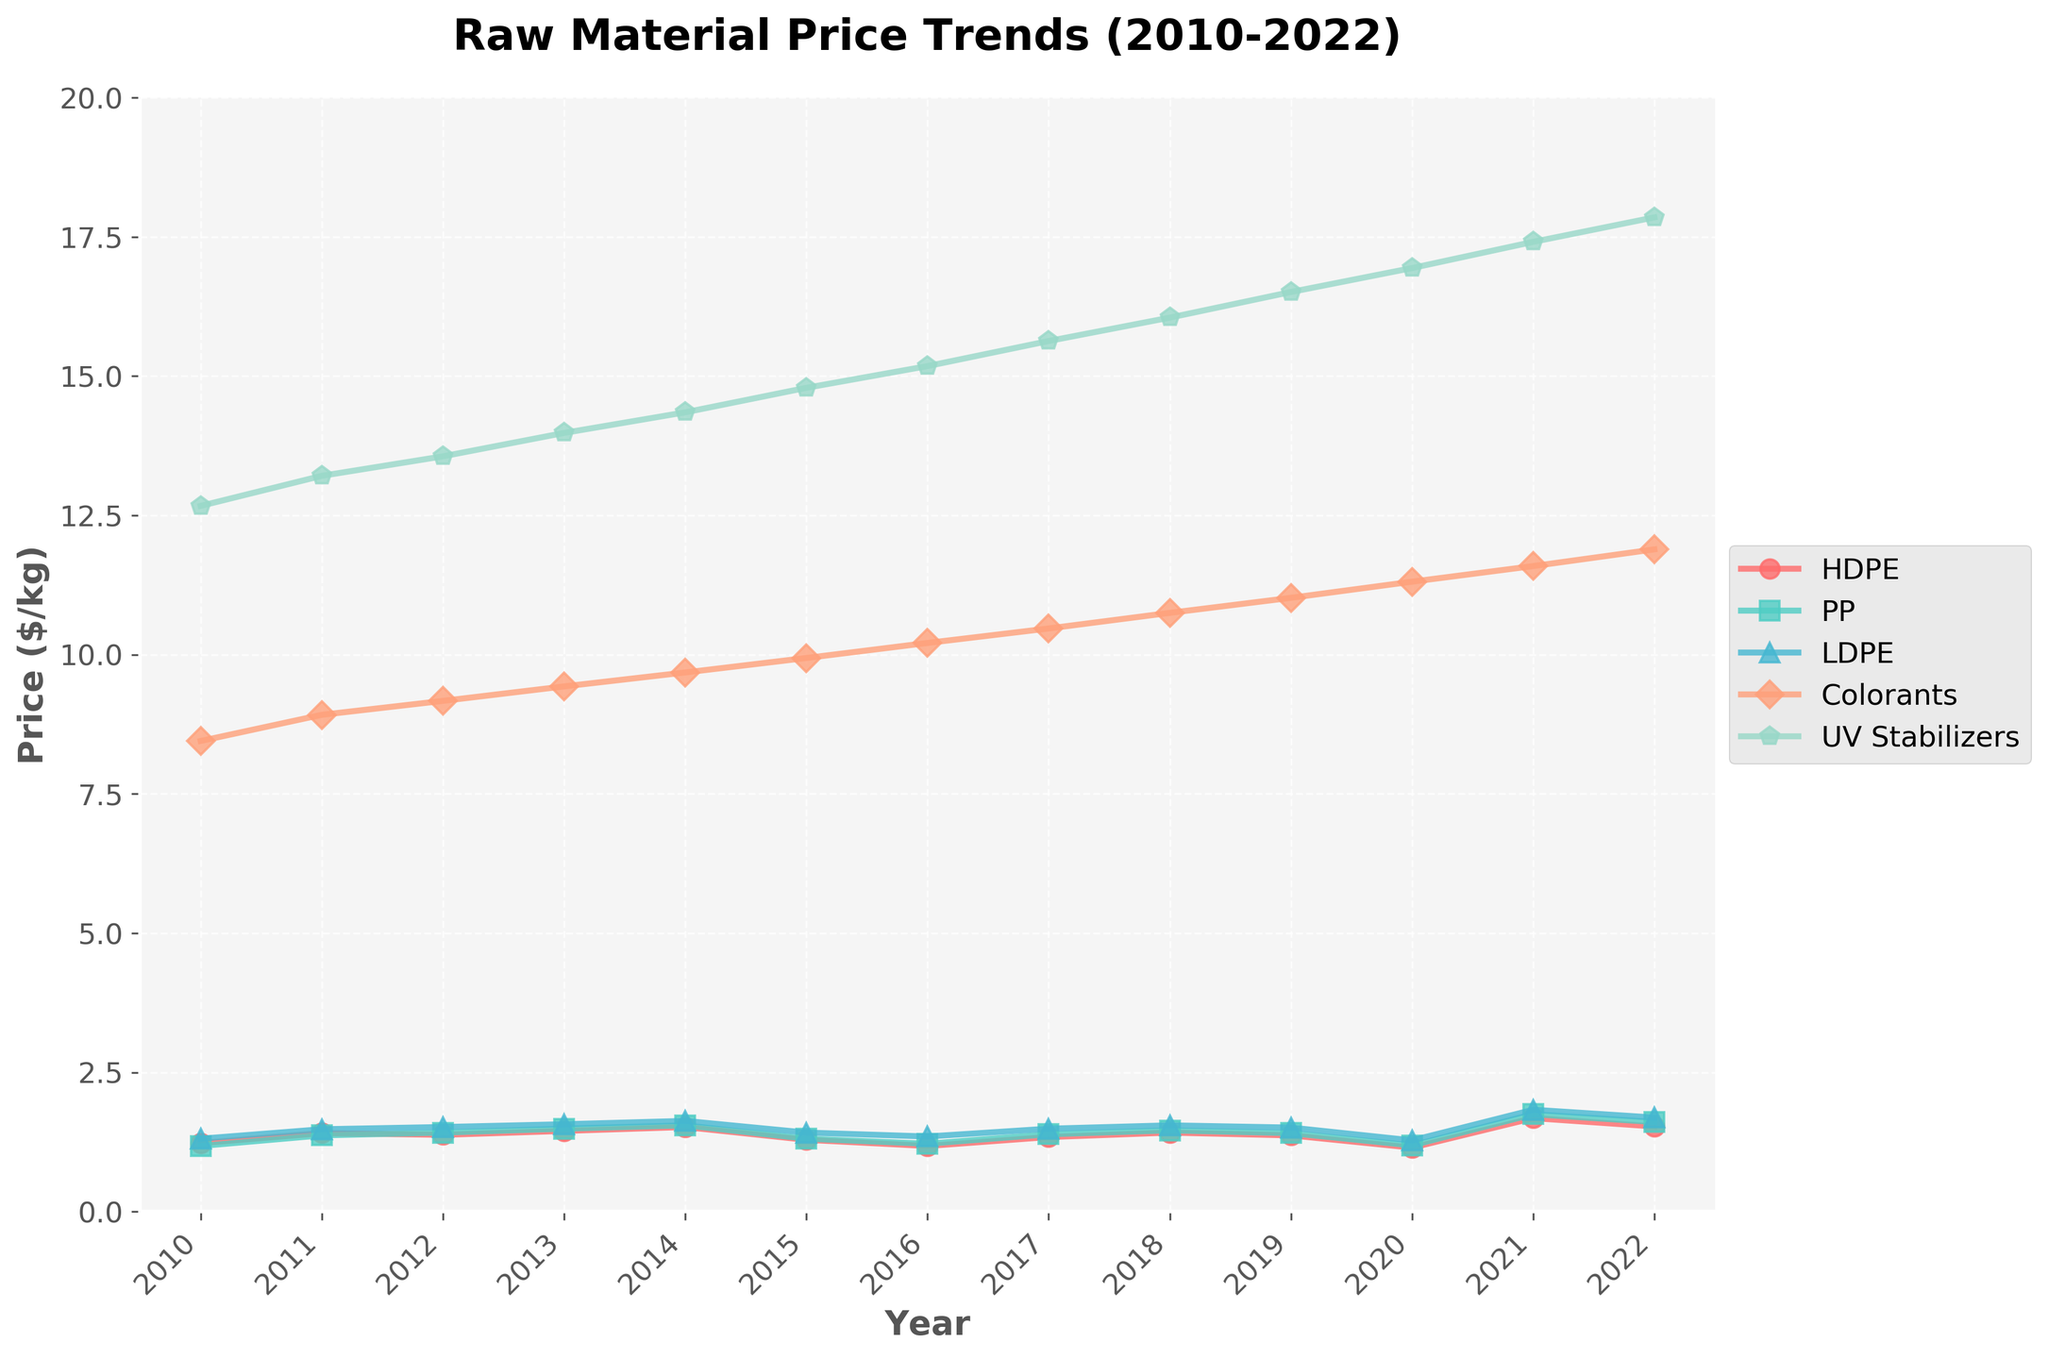Which material had the highest price in 2020? The y-axis represents the price in $/kg, and by looking at the year 2020 on the x-axis, we see that UV Stabilizers had the highest price.
Answer: UV Stabilizers Between 2010 and 2022, in which year did HDPE experience its sharpest price increase? By examining the line representing HDPE (red) and comparing the slope between consecutive years, we observe the steepest increase between 2020 and 2021.
Answer: 2021 How much did the price of Colorants change from 2015 to 2020? Checking the values for 2015 ($9.94/kg) and 2020 ($11.31/kg) on the Colorants line (orange), the change is calculated as $11.31 - $9.94.
Answer: 1.37 Which material had the least price fluctuation over the entire period? Visually, the lines for HDPE, PP, LDPE, Colorants, and UV Stabilizers can be compared. The line that seems the flattest is for PP (green).
Answer: PP In which year did the price of LDPE first exceed $1.50/kg? Referring to the LDPE line (blue), it first crosses the $1.50/kg mark between 2011 and 2012.
Answer: 2012 By how much did the price of UV Stabilizers increase from 2016 to 2022? Observing the prices at 2016 ($15.18/kg) and 2022 ($17.85/kg) on the UV Stabilizers line (teal), the increase is $17.85 - $15.18.
Answer: 2.67 Compare the prices of HDPE and PP in 2018. Which was more expensive and by how much? For 2018, the prices are $1.42/kg for HDPE and $1.46/kg for PP. Subtract the two to find the difference.
Answer: PP by 0.04 Identify the years in which the price of Colorants was increasing. By checking the Colorants line (orange), the price increases consistently over the entire period from 2010 to 2022, except between any dip or flat region.
Answer: 2010-2022 (overall trend) What is the average price of HDPE over the entire period? Summing the HDPE prices for all years and dividing by the number of years (13): (1.23 + 1.41 + 1.38 + 1.45 + 1.52 + 1.29 + 1.18 + 1.34 + 1.42 + 1.37 + 1.15 + 1.68 + 1.53) / 13.
Answer: ~1.39 Which material showed a dramatic price increase during 2021? The year 2021 saw the steepest increase for the HDPE line (red), jumping from $1.15/kg in 2020 to $1.68/kg in 2021.
Answer: HDPE 